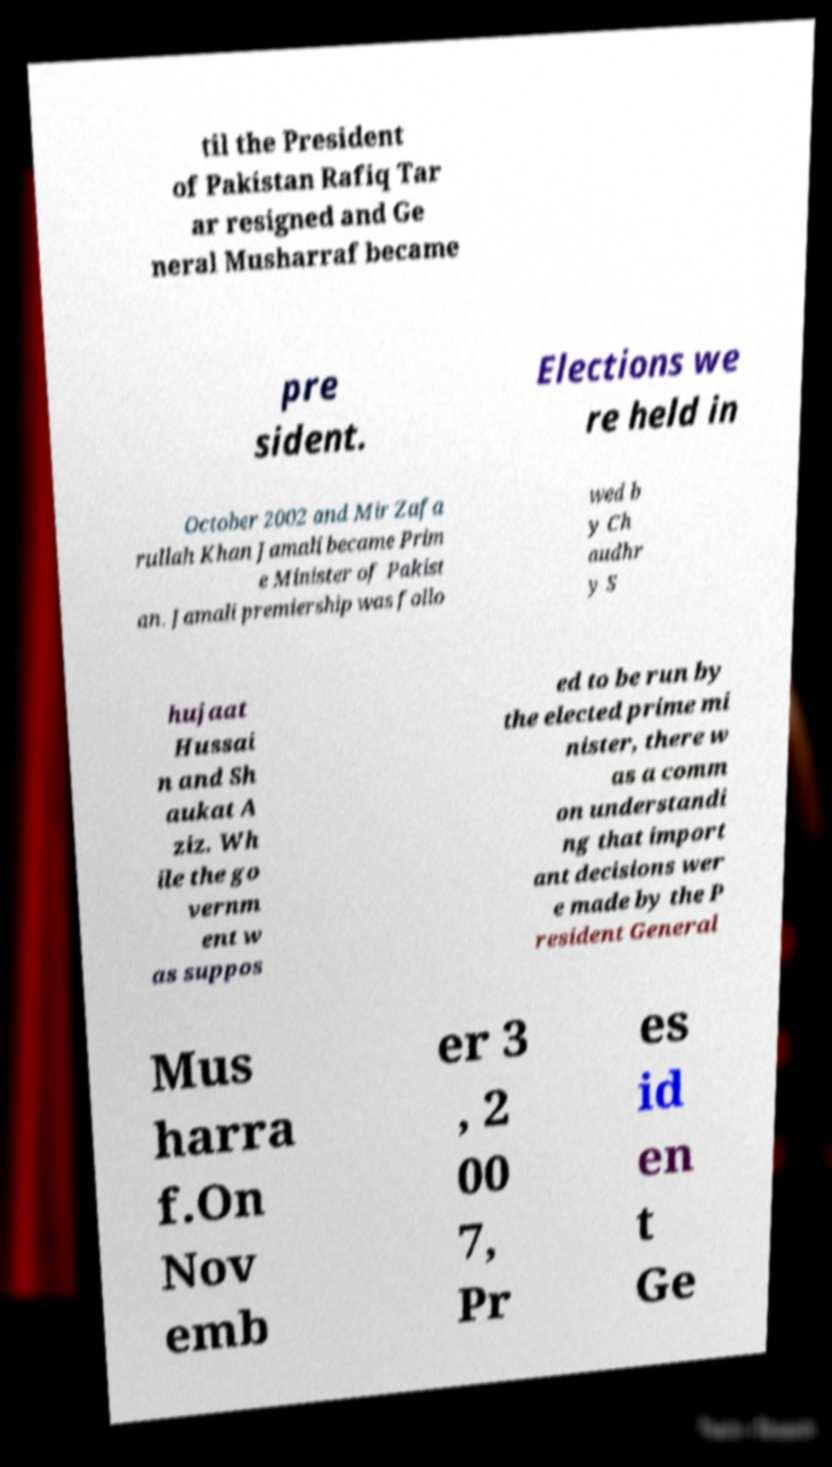What messages or text are displayed in this image? I need them in a readable, typed format. til the President of Pakistan Rafiq Tar ar resigned and Ge neral Musharraf became pre sident. Elections we re held in October 2002 and Mir Zafa rullah Khan Jamali became Prim e Minister of Pakist an. Jamali premiership was follo wed b y Ch audhr y S hujaat Hussai n and Sh aukat A ziz. Wh ile the go vernm ent w as suppos ed to be run by the elected prime mi nister, there w as a comm on understandi ng that import ant decisions wer e made by the P resident General Mus harra f.On Nov emb er 3 , 2 00 7, Pr es id en t Ge 